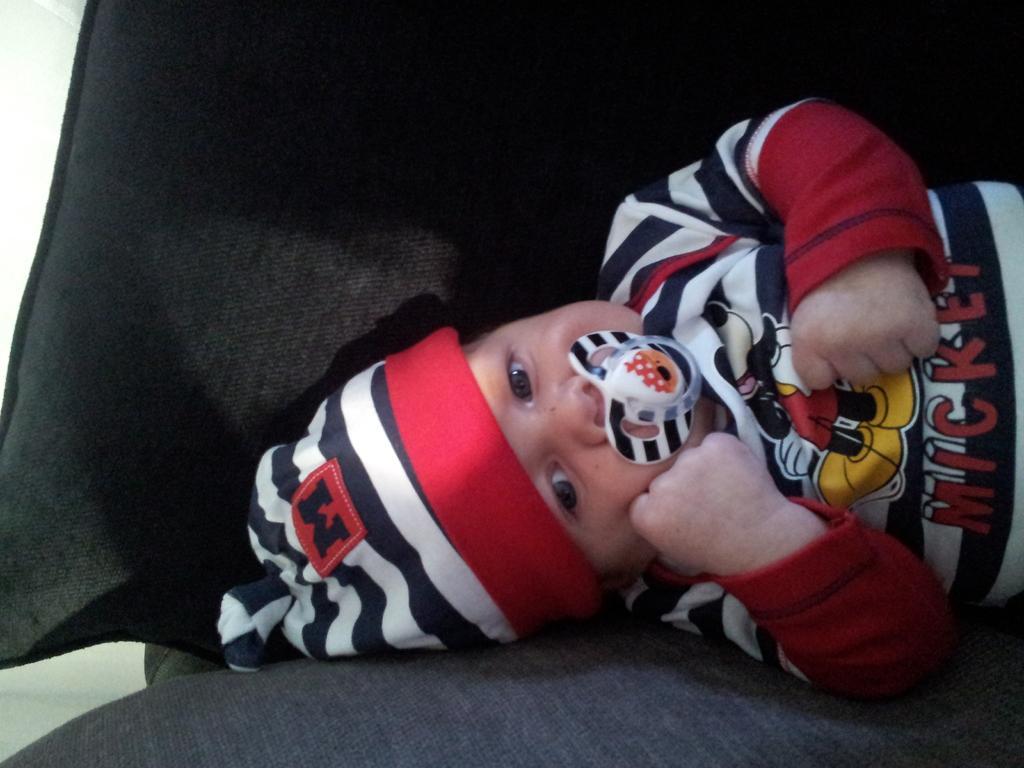In one or two sentences, can you explain what this image depicts? In the picture I can see a baby sleeping on the sofa. The baby is wearing the clothes and there is a cap on the head. I can see the milky nipple in the mouth. 